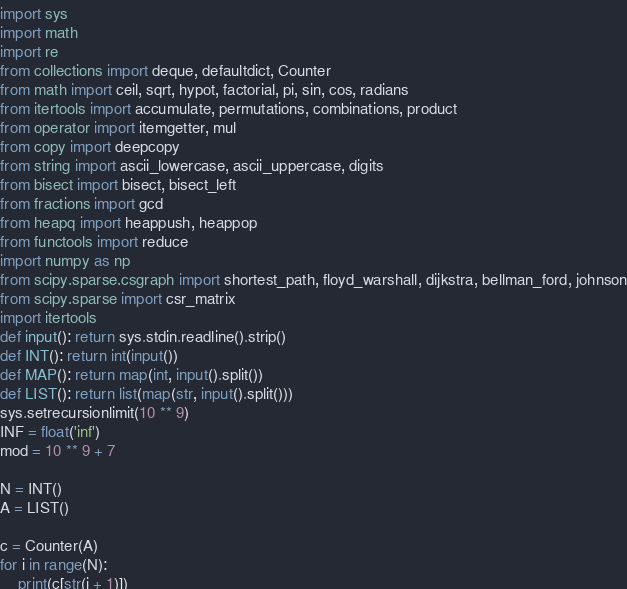<code> <loc_0><loc_0><loc_500><loc_500><_Python_>import sys
import math
import re
from collections import deque, defaultdict, Counter
from math import ceil, sqrt, hypot, factorial, pi, sin, cos, radians
from itertools import accumulate, permutations, combinations, product
from operator import itemgetter, mul
from copy import deepcopy
from string import ascii_lowercase, ascii_uppercase, digits
from bisect import bisect, bisect_left
from fractions import gcd
from heapq import heappush, heappop
from functools import reduce
import numpy as np
from scipy.sparse.csgraph import shortest_path, floyd_warshall, dijkstra, bellman_ford, johnson
from scipy.sparse import csr_matrix
import itertools
def input(): return sys.stdin.readline().strip()
def INT(): return int(input())
def MAP(): return map(int, input().split())
def LIST(): return list(map(str, input().split()))
sys.setrecursionlimit(10 ** 9)
INF = float('inf')
mod = 10 ** 9 + 7

N = INT()
A = LIST()

c = Counter(A)
for i in range(N):
    print(c[str(i + 1)])
</code> 